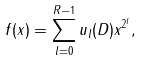<formula> <loc_0><loc_0><loc_500><loc_500>f ( x ) = \sum _ { l = 0 } ^ { R - 1 } u _ { l } ( D ) x ^ { 2 ^ { l } } ,</formula> 